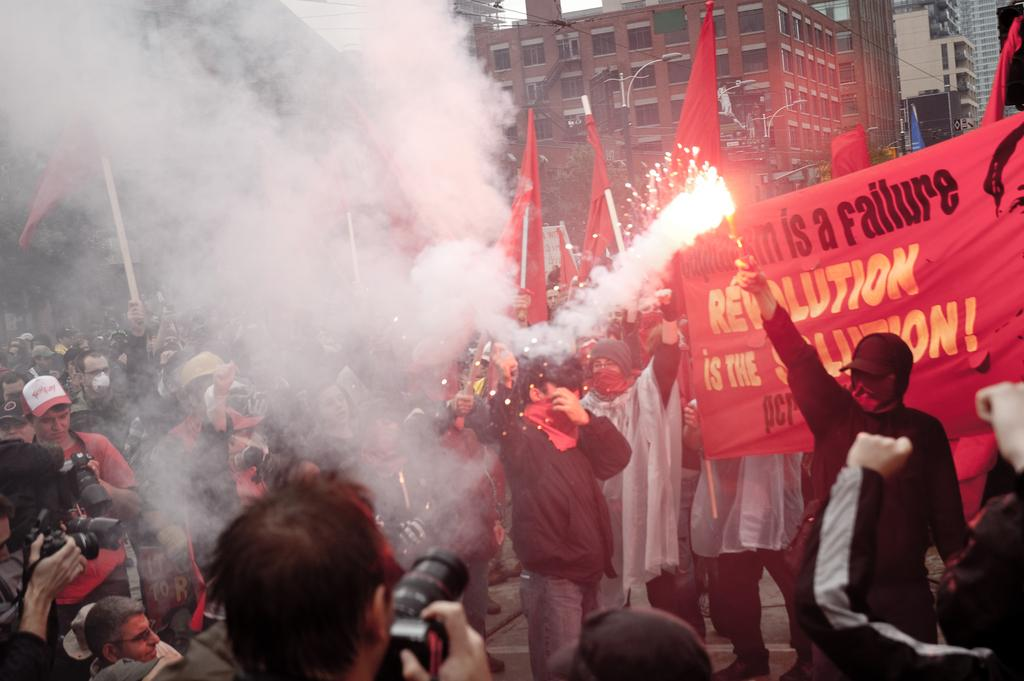<image>
Present a compact description of the photo's key features. A protest going on with a sign saying revolution is the solution 